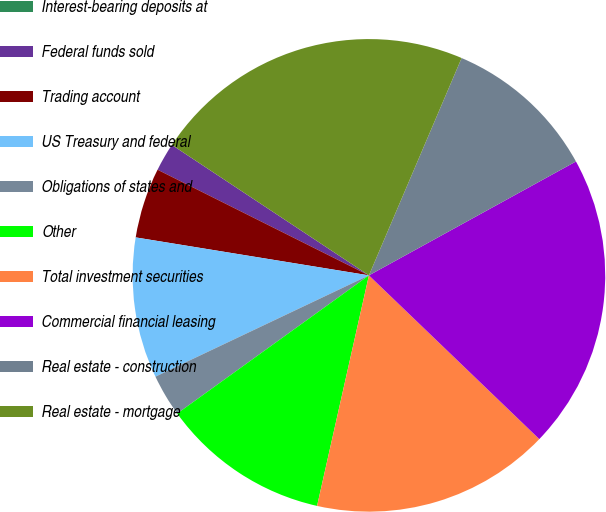Convert chart to OTSL. <chart><loc_0><loc_0><loc_500><loc_500><pie_chart><fcel>Interest-bearing deposits at<fcel>Federal funds sold<fcel>Trading account<fcel>US Treasury and federal<fcel>Obligations of states and<fcel>Other<fcel>Total investment securities<fcel>Commercial financial leasing<fcel>Real estate - construction<fcel>Real estate - mortgage<nl><fcel>0.0%<fcel>1.93%<fcel>4.81%<fcel>9.62%<fcel>2.89%<fcel>11.54%<fcel>16.34%<fcel>20.19%<fcel>10.58%<fcel>22.11%<nl></chart> 